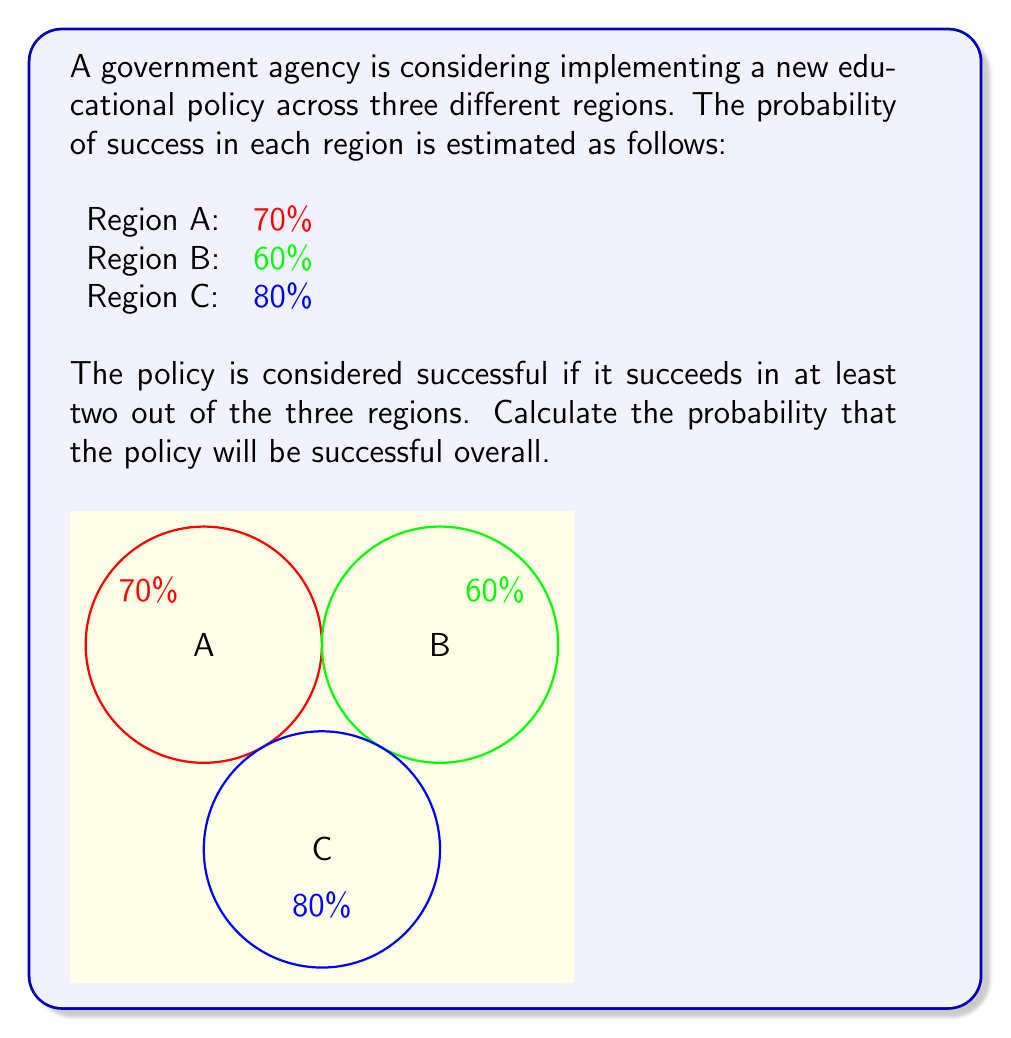Show me your answer to this math problem. To solve this problem, we need to use the concept of probability for multiple independent events. Let's approach this step-by-step:

1) First, let's define our events:
   A: Success in Region A (P(A) = 0.7)
   B: Success in Region B (P(B) = 0.6)
   C: Success in Region C (P(C) = 0.8)

2) The policy is successful if it succeeds in at least two regions. This can happen in four ways:
   - Success in all three regions (A ∩ B ∩ C)
   - Success in A and B, but not C (A ∩ B ∩ C')
   - Success in A and C, but not B (A ∩ B' ∩ C)
   - Success in B and C, but not A (A' ∩ B ∩ C)

3) Let's calculate the probability of each:

   P(A ∩ B ∩ C) = 0.7 * 0.6 * 0.8 = 0.336
   P(A ∩ B ∩ C') = 0.7 * 0.6 * 0.2 = 0.084
   P(A ∩ B' ∩ C) = 0.7 * 0.4 * 0.8 = 0.224
   P(A' ∩ B ∩ C) = 0.3 * 0.6 * 0.8 = 0.144

4) The total probability is the sum of these individual probabilities:

   P(success) = 0.336 + 0.084 + 0.224 + 0.144 = 0.788

5) Therefore, the probability of the policy being successful is 0.788 or 78.8%.
Answer: 0.788 or 78.8% 